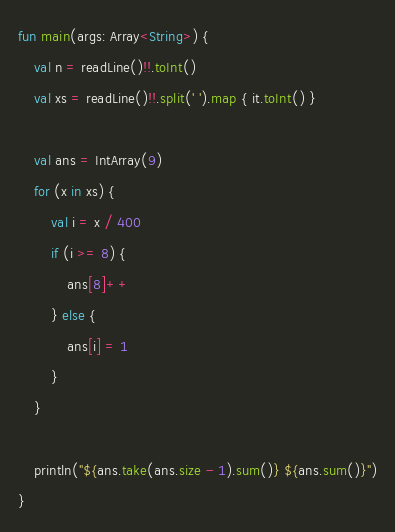Convert code to text. <code><loc_0><loc_0><loc_500><loc_500><_Kotlin_>fun main(args: Array<String>) {
    val n = readLine()!!.toInt()
    val xs = readLine()!!.split(' ').map { it.toInt() }

    val ans = IntArray(9)
    for (x in xs) {
        val i = x / 400
        if (i >= 8) {
            ans[8]++
        } else {
            ans[i] = 1
        }
    }

    println("${ans.take(ans.size - 1).sum()} ${ans.sum()}")
}
</code> 